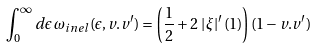Convert formula to latex. <formula><loc_0><loc_0><loc_500><loc_500>\int _ { 0 } ^ { \infty } d \epsilon \, \omega _ { i n e l } ( \epsilon , v . v ^ { \prime } ) = \left ( \frac { 1 } { 2 } + 2 \, \left | \xi \right | ^ { \prime } ( 1 ) \right ) ( 1 - v . v ^ { \prime } )</formula> 